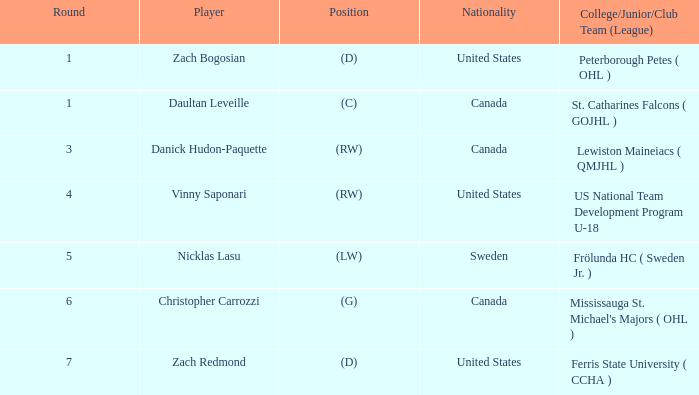What is the competitor in round 5? Nicklas Lasu. 